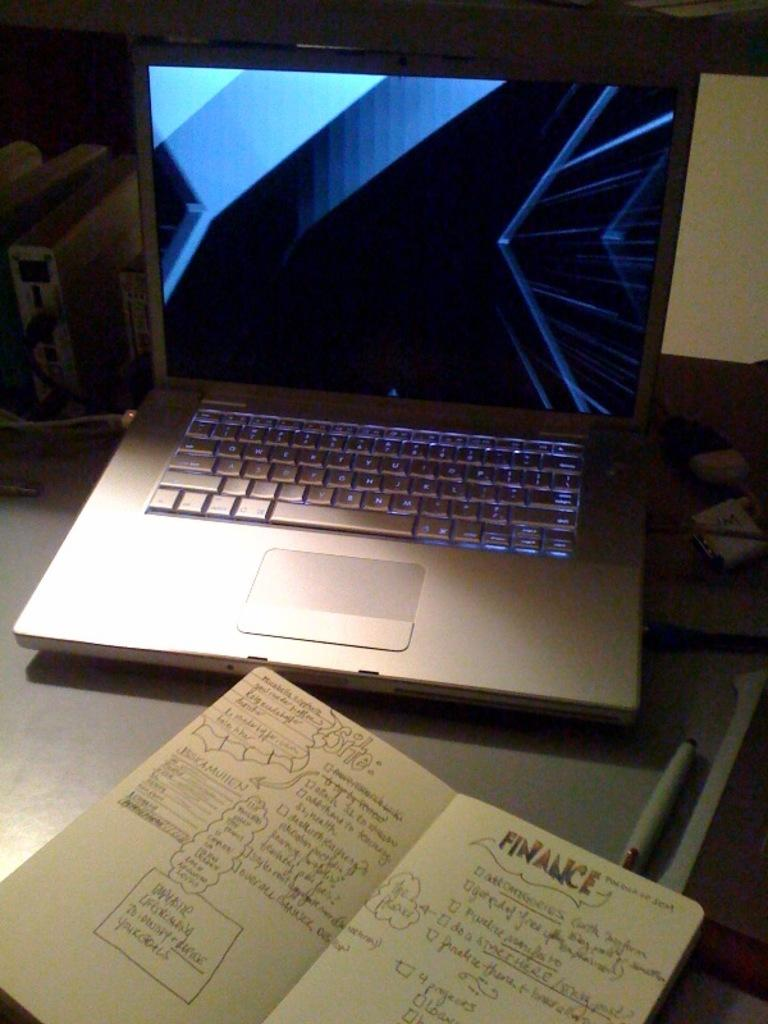<image>
Provide a brief description of the given image. The heading on a page of text is "Finance." 